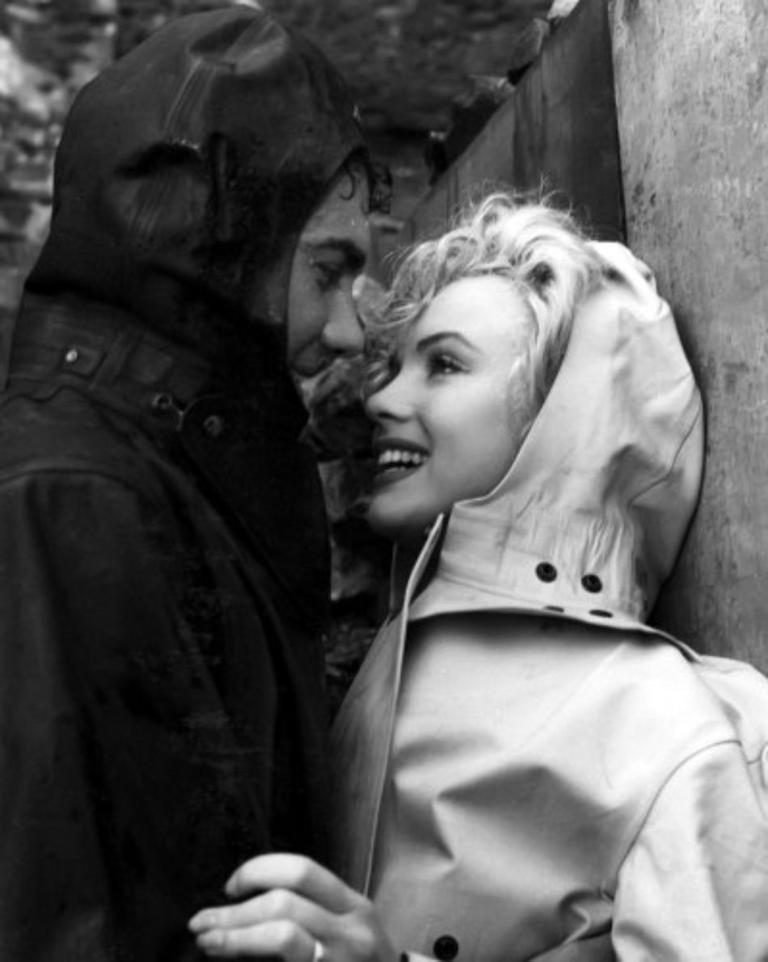What is the color scheme of the image? The image is black and white. Who can be seen in the image? There is a woman and at least one man in the image. How are the woman and man positioned in relation to each other? The woman and man are facing each other. Can you describe the background of the image? The background of the image is blurry. What type of plant is being washed in the drain in the image? There is no plant or drain present in the image. 